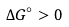<formula> <loc_0><loc_0><loc_500><loc_500>\Delta G ^ { \circ } > 0</formula> 